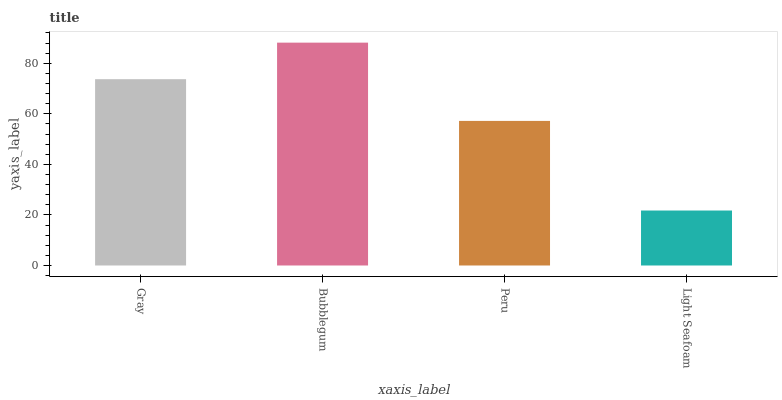Is Light Seafoam the minimum?
Answer yes or no. Yes. Is Bubblegum the maximum?
Answer yes or no. Yes. Is Peru the minimum?
Answer yes or no. No. Is Peru the maximum?
Answer yes or no. No. Is Bubblegum greater than Peru?
Answer yes or no. Yes. Is Peru less than Bubblegum?
Answer yes or no. Yes. Is Peru greater than Bubblegum?
Answer yes or no. No. Is Bubblegum less than Peru?
Answer yes or no. No. Is Gray the high median?
Answer yes or no. Yes. Is Peru the low median?
Answer yes or no. Yes. Is Bubblegum the high median?
Answer yes or no. No. Is Bubblegum the low median?
Answer yes or no. No. 